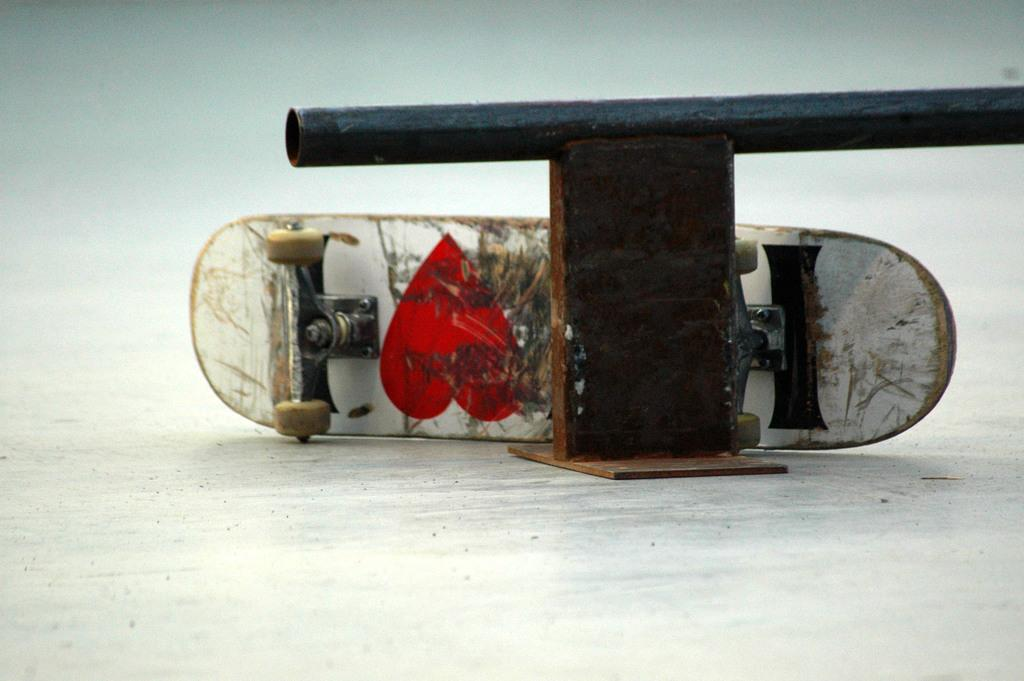What object is the main focus of the image? There is a skateboard in the image. What is depicted on the skateboard? There is a sketch on the skateboard. What type of river is flowing near the skateboard in the image? There is no river present in the image; it only features a skateboard with a sketch on it. What kind of apparel is the skateboarder wearing in the image? There is no skateboarder present in the image, only the skateboard with a sketch on it. 